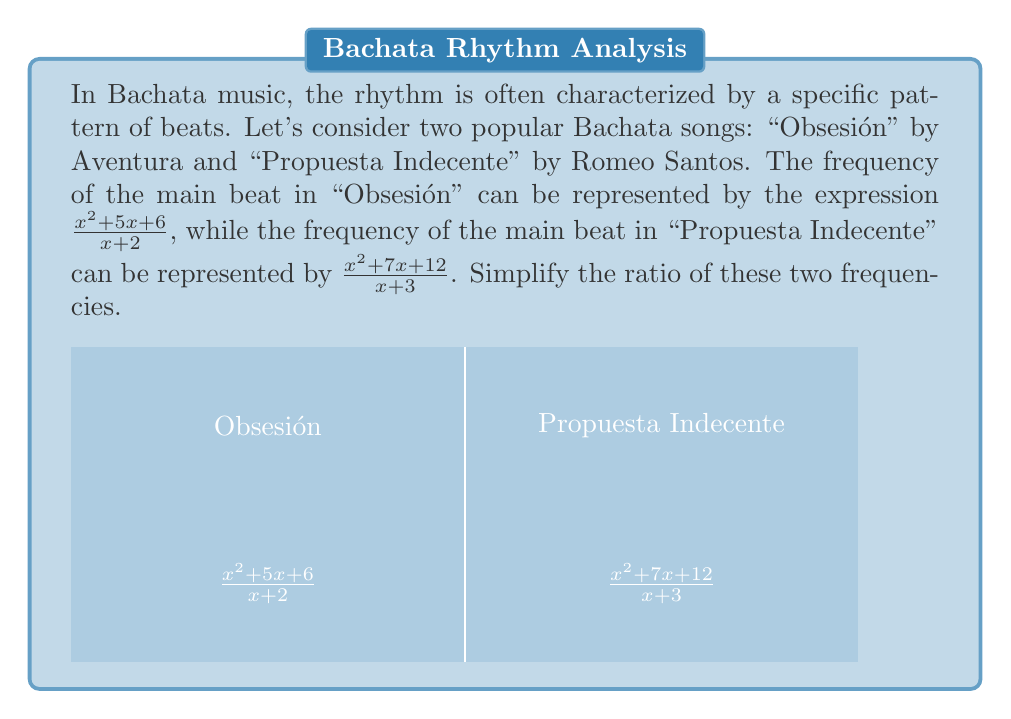Solve this math problem. Let's approach this step-by-step:

1) The ratio of the two frequencies is:

   $$\frac{\frac{x^2 + 5x + 6}{x + 2}}{\frac{x^2 + 7x + 12}{x + 3}}$$

2) To simplify this, we can multiply the first fraction by the reciprocal of the second:

   $$\frac{x^2 + 5x + 6}{x + 2} \cdot \frac{x + 3}{x^2 + 7x + 12}$$

3) Now, let's factor the numerators and denominators:

   $$\frac{(x + 2)(x + 3)}{x + 2} \cdot \frac{x + 3}{(x + 3)(x + 4)}$$

4) The $(x + 2)$ cancels out in the first fraction, and $(x + 3)$ cancels out between the two fractions:

   $$\frac{x + 3}{x + 4}$$

5) This fraction cannot be simplified further as the numerator and denominator have no common factors.

Therefore, the simplified ratio of the frequencies is $\frac{x + 3}{x + 4}$.
Answer: $\frac{x + 3}{x + 4}$ 